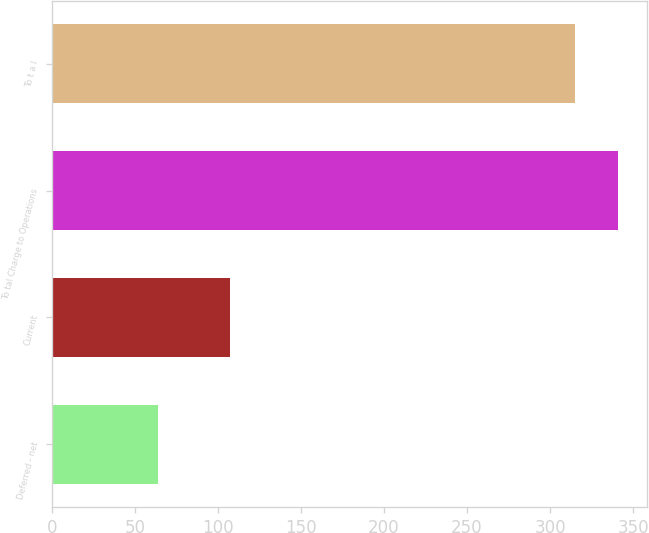Convert chart. <chart><loc_0><loc_0><loc_500><loc_500><bar_chart><fcel>Deferred - net<fcel>Current<fcel>To tal Charge to Operations<fcel>To t a l<nl><fcel>64<fcel>107<fcel>341.1<fcel>315<nl></chart> 